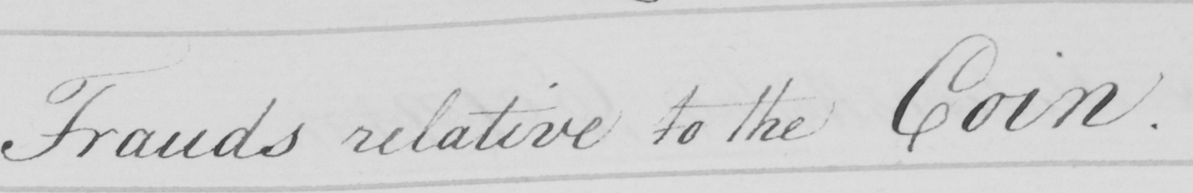What does this handwritten line say? Frauds relative to the Coin . 